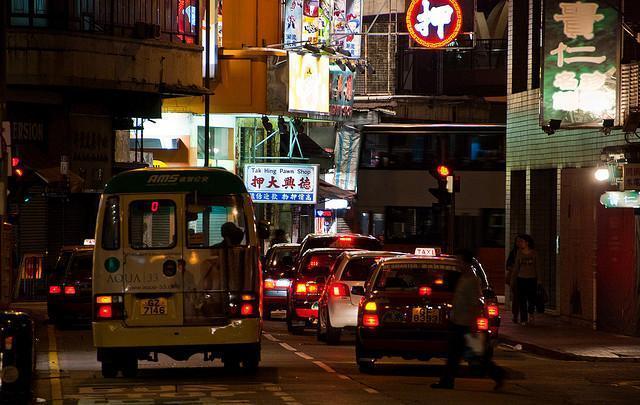How many vehicles are in the picture?
Give a very brief answer. 7. How many cars can you see?
Give a very brief answer. 5. 